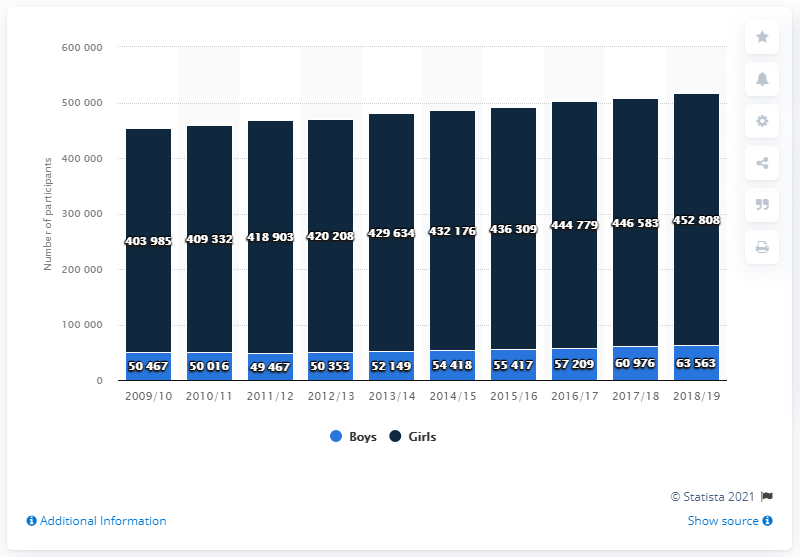Draw attention to some important aspects in this diagram. In the 2018/19 school year, a total of 452,808 girls participated in high school volleyball programs. 